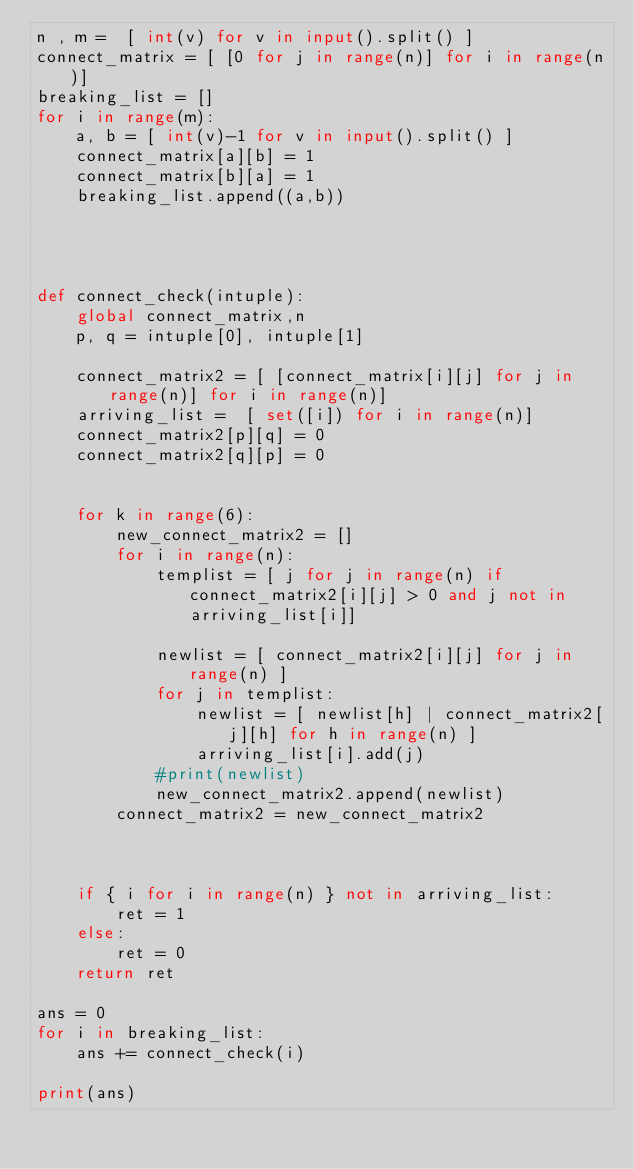<code> <loc_0><loc_0><loc_500><loc_500><_Python_>n , m =  [ int(v) for v in input().split() ]
connect_matrix = [ [0 for j in range(n)] for i in range(n)]
breaking_list = []
for i in range(m):
    a, b = [ int(v)-1 for v in input().split() ]
    connect_matrix[a][b] = 1
    connect_matrix[b][a] = 1
    breaking_list.append((a,b))




def connect_check(intuple):
    global connect_matrix,n
    p, q = intuple[0], intuple[1]

    connect_matrix2 = [ [connect_matrix[i][j] for j in range(n)] for i in range(n)]
    arriving_list =  [ set([i]) for i in range(n)]
    connect_matrix2[p][q] = 0
    connect_matrix2[q][p] = 0

    
    for k in range(6):
        new_connect_matrix2 = []
        for i in range(n):
            templist = [ j for j in range(n) if connect_matrix2[i][j] > 0 and j not in arriving_list[i]]

            newlist = [ connect_matrix2[i][j] for j in range(n) ]
            for j in templist:
                newlist = [ newlist[h] | connect_matrix2[j][h] for h in range(n) ]
                arriving_list[i].add(j)
            #print(newlist)
            new_connect_matrix2.append(newlist)
        connect_matrix2 = new_connect_matrix2


    
    if { i for i in range(n) } not in arriving_list:
        ret = 1
    else:
        ret = 0
    return ret

ans = 0
for i in breaking_list:
    ans += connect_check(i)

print(ans)</code> 